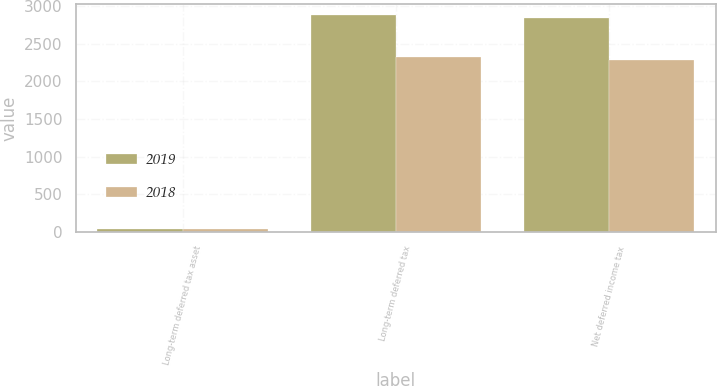Convert chart. <chart><loc_0><loc_0><loc_500><loc_500><stacked_bar_chart><ecel><fcel>Long-term deferred tax asset<fcel>Long-term deferred tax<fcel>Net deferred income tax<nl><fcel>2019<fcel>33.5<fcel>2878<fcel>2844.5<nl><fcel>2018<fcel>35.2<fcel>2321.5<fcel>2286.3<nl></chart> 